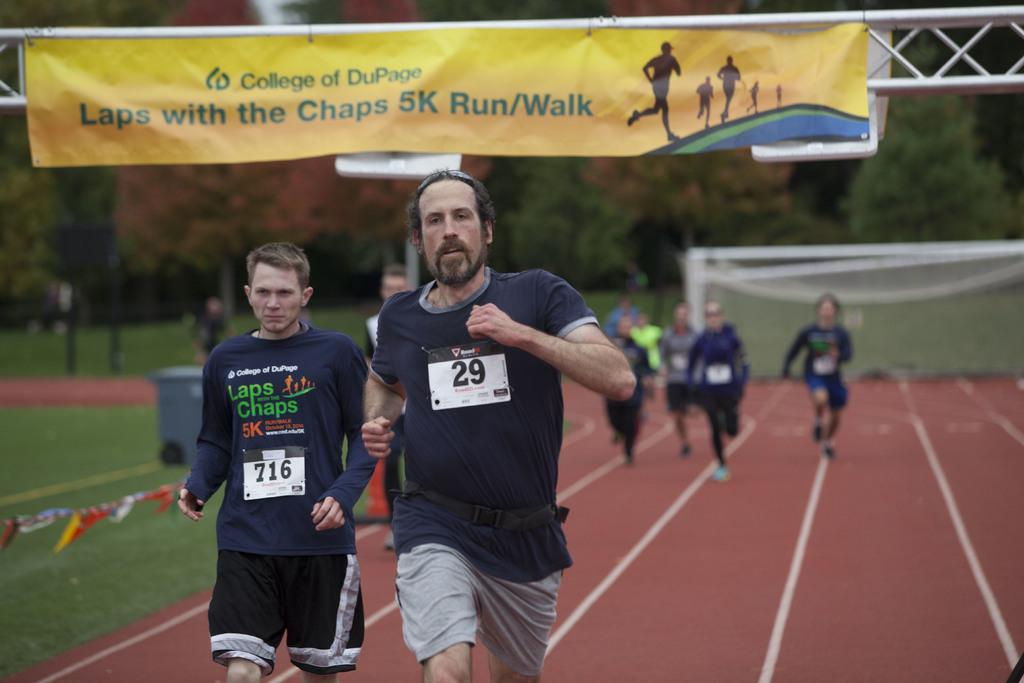What are the persons in the foreground of the image doing? The persons in the foreground of the image are running on the ground. What can be seen in the background of the image? In the background of the image, there are persons running on the ground, grass, a dustbin, trees, and a banner. What type of vegetation is visible in the background of the image? Trees are visible in the background of the image. What is the purpose of the banner in the background of the image? The purpose of the banner in the background of the image cannot be determined from the facts provided. What type of music is being played by the governor in the image? There is no governor or music present in the image. Can you make a request to the person running in the background of the image? The image does not allow for direct interaction or communication with the persons running in the image. 